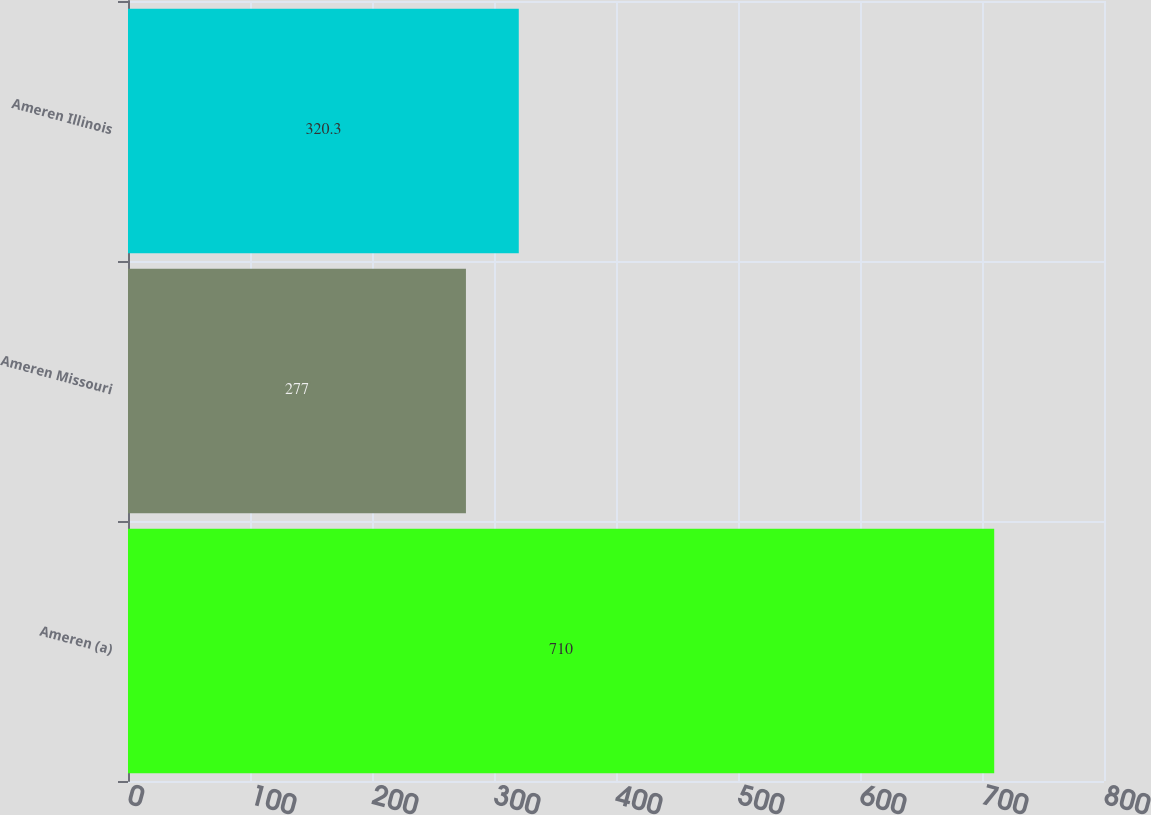<chart> <loc_0><loc_0><loc_500><loc_500><bar_chart><fcel>Ameren (a)<fcel>Ameren Missouri<fcel>Ameren Illinois<nl><fcel>710<fcel>277<fcel>320.3<nl></chart> 